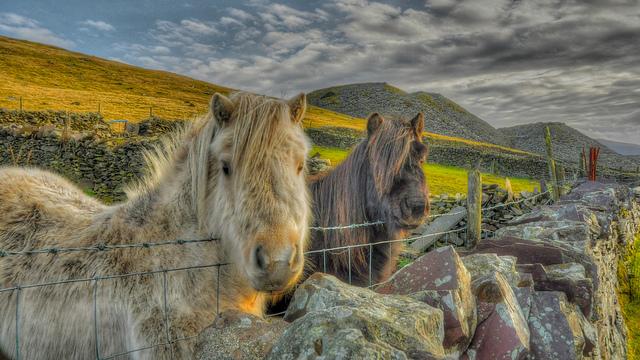What animals are in the image?
Write a very short answer. Horses. Is this a painting or real?
Give a very brief answer. Real. When was the picture taken?
Answer briefly. Daytime. 